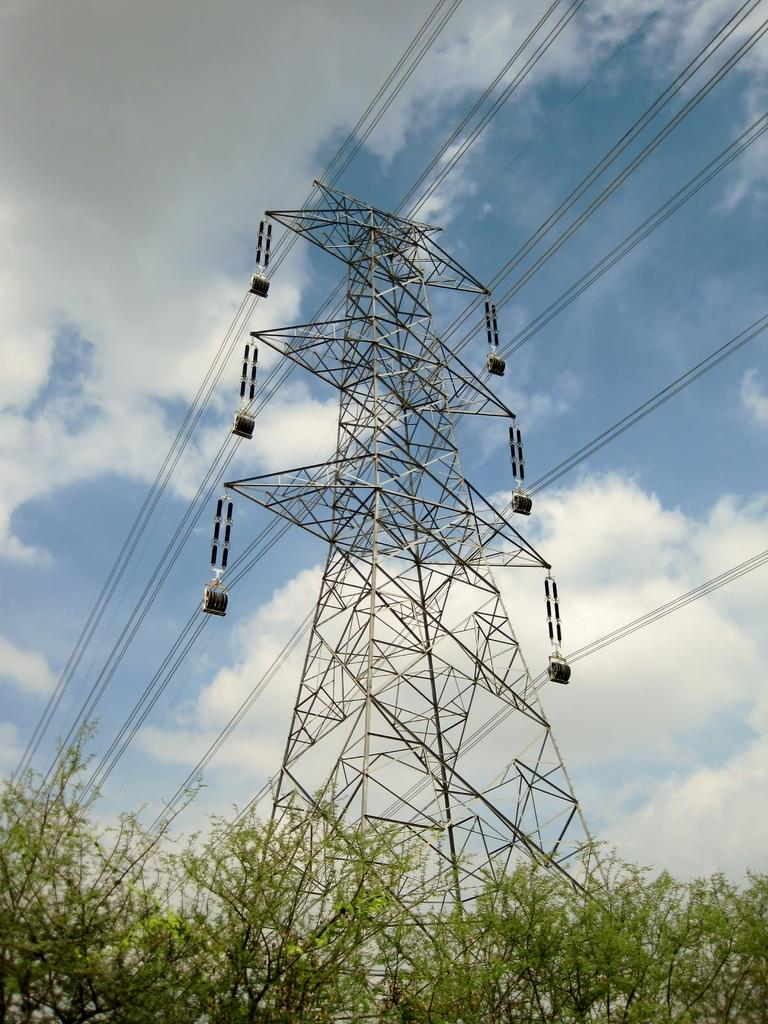What type of vegetation is at the bottom of the image? There are trees at the bottom of the image. What structure is located in the middle of the image? There is a transmission tower in the middle of the image. What is connected to the transmission tower? There are wires associated with the transmission tower. What can be seen in the background of the image? Clouds and the sky are visible in the background of the image. Where is the doll located in the image? There is no doll present in the image. What type of form is visible in the hall in the image? There is no hall or form present in the image. 